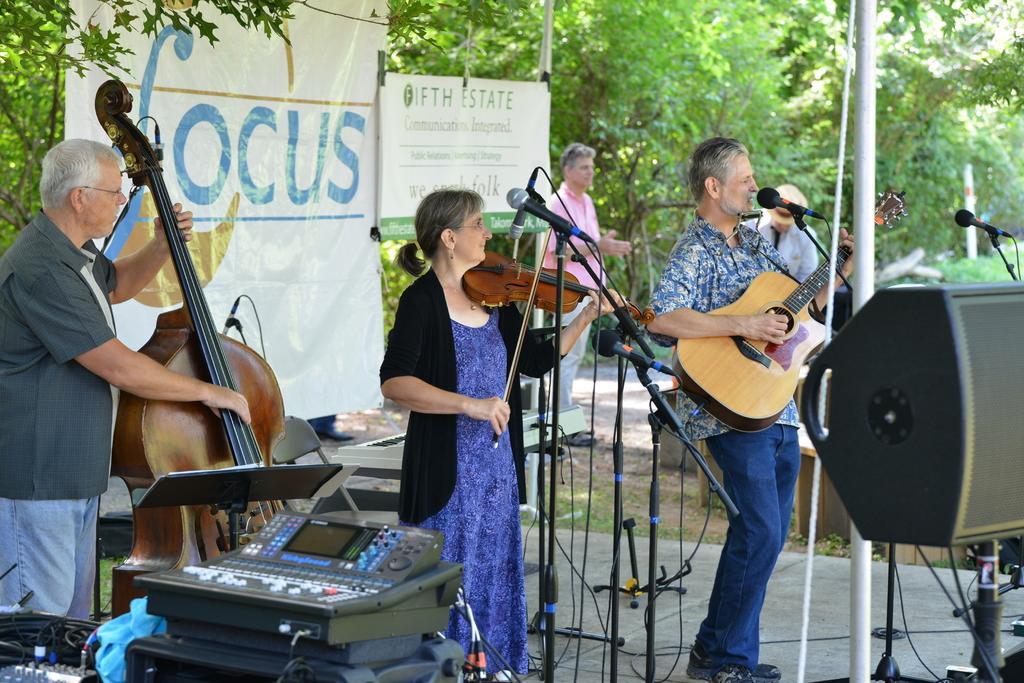Please provide a concise description of this image. In the image there are five people four man and one woman. Who is holding her violin in front of a microphone and playing it from left side to right side two men's are playing their musical instrument. On right side there are two men who are standing in background there is hoardings,trees. 